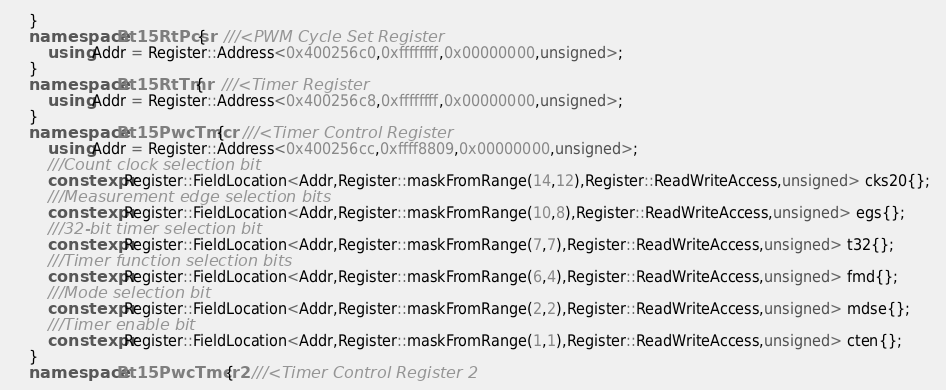<code> <loc_0><loc_0><loc_500><loc_500><_C++_>    }
    namespace Bt15RtPcsr{    ///<PWM Cycle Set Register
        using Addr = Register::Address<0x400256c0,0xffffffff,0x00000000,unsigned>;
    }
    namespace Bt15RtTmr{    ///<Timer Register
        using Addr = Register::Address<0x400256c8,0xffffffff,0x00000000,unsigned>;
    }
    namespace Bt15PwcTmcr{    ///<Timer Control Register
        using Addr = Register::Address<0x400256cc,0xffff8809,0x00000000,unsigned>;
        ///Count clock selection bit 
        constexpr Register::FieldLocation<Addr,Register::maskFromRange(14,12),Register::ReadWriteAccess,unsigned> cks20{}; 
        ///Measurement edge selection bits 
        constexpr Register::FieldLocation<Addr,Register::maskFromRange(10,8),Register::ReadWriteAccess,unsigned> egs{}; 
        ///32-bit timer selection bit 
        constexpr Register::FieldLocation<Addr,Register::maskFromRange(7,7),Register::ReadWriteAccess,unsigned> t32{}; 
        ///Timer function selection bits 
        constexpr Register::FieldLocation<Addr,Register::maskFromRange(6,4),Register::ReadWriteAccess,unsigned> fmd{}; 
        ///Mode selection bit 
        constexpr Register::FieldLocation<Addr,Register::maskFromRange(2,2),Register::ReadWriteAccess,unsigned> mdse{}; 
        ///Timer enable bit 
        constexpr Register::FieldLocation<Addr,Register::maskFromRange(1,1),Register::ReadWriteAccess,unsigned> cten{}; 
    }
    namespace Bt15PwcTmcr2{    ///<Timer Control Register 2</code> 